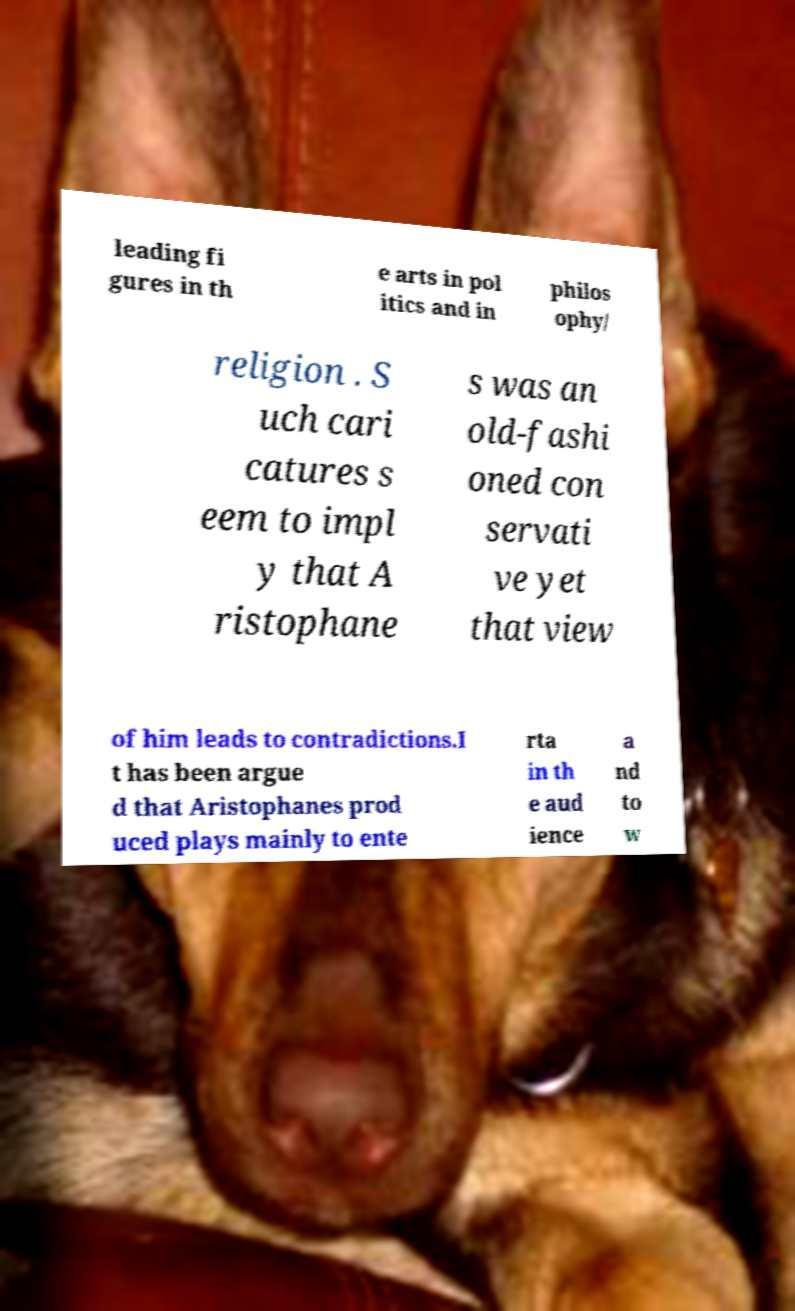For documentation purposes, I need the text within this image transcribed. Could you provide that? leading fi gures in th e arts in pol itics and in philos ophy/ religion . S uch cari catures s eem to impl y that A ristophane s was an old-fashi oned con servati ve yet that view of him leads to contradictions.I t has been argue d that Aristophanes prod uced plays mainly to ente rta in th e aud ience a nd to w 